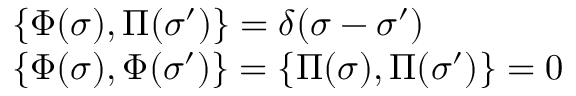<formula> <loc_0><loc_0><loc_500><loc_500>\begin{array} { l l } { { \{ \Phi ( \sigma ) , \Pi ( \sigma ^ { \prime } ) \} = \delta ( \sigma - \sigma ^ { \prime } ) } } \\ { { \{ \Phi ( \sigma ) , \Phi ( \sigma ^ { \prime } ) \} = \{ \Pi ( \sigma ) , \Pi ( \sigma ^ { \prime } ) \} = 0 } } \end{array}</formula> 